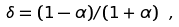Convert formula to latex. <formula><loc_0><loc_0><loc_500><loc_500>\delta = ( 1 - \alpha ) / ( 1 + \alpha ) \ ,</formula> 